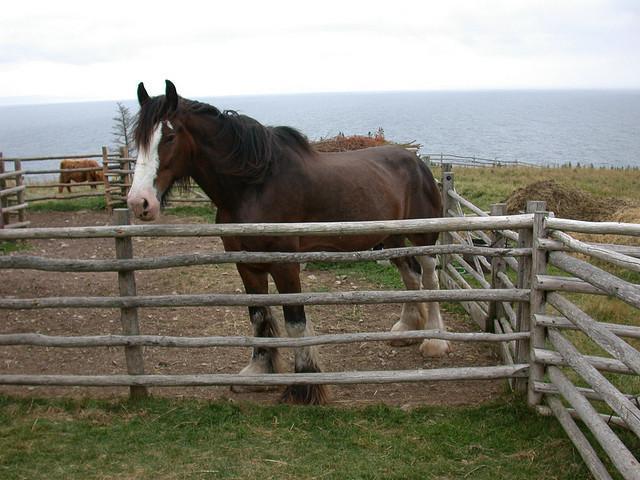How many horses are in the photo?
Give a very brief answer. 1. How many people are wearing a black shirt?
Give a very brief answer. 0. 